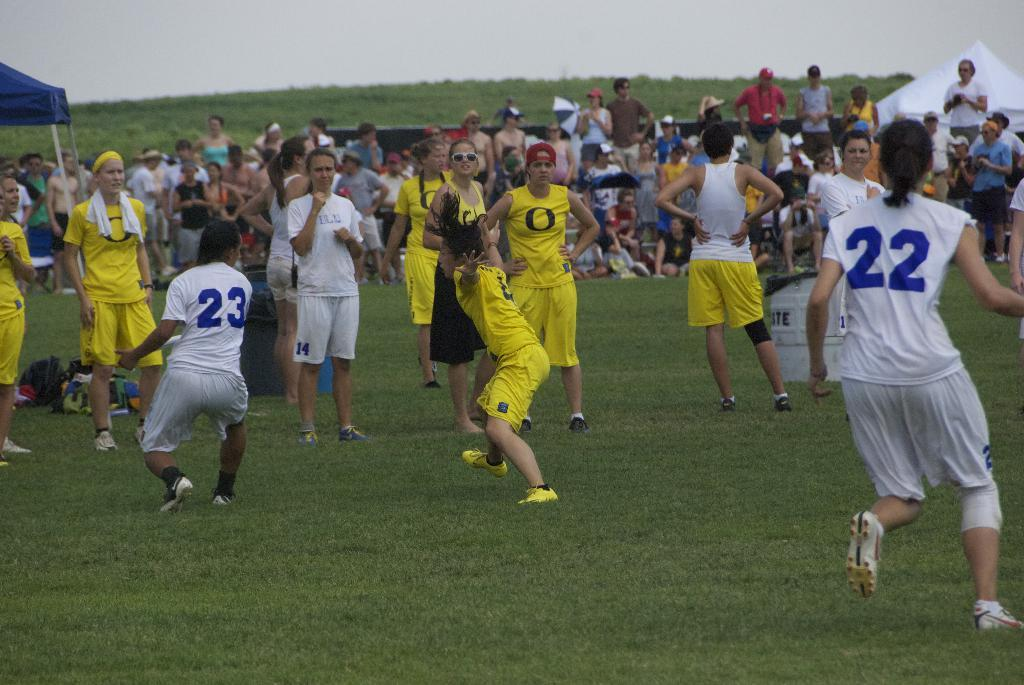<image>
Present a compact description of the photo's key features. Blue and white players #22 and #23 are seen on the field against several yellow players with an O an their jerseys. 